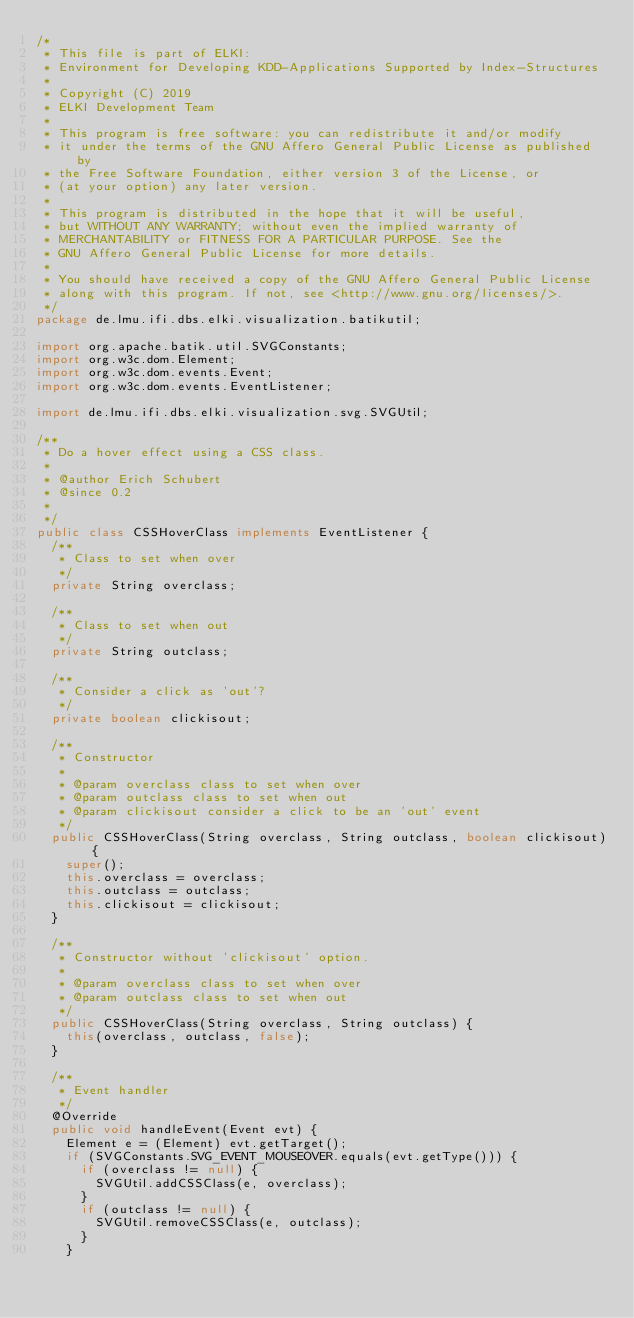Convert code to text. <code><loc_0><loc_0><loc_500><loc_500><_Java_>/*
 * This file is part of ELKI:
 * Environment for Developing KDD-Applications Supported by Index-Structures
 *
 * Copyright (C) 2019
 * ELKI Development Team
 *
 * This program is free software: you can redistribute it and/or modify
 * it under the terms of the GNU Affero General Public License as published by
 * the Free Software Foundation, either version 3 of the License, or
 * (at your option) any later version.
 *
 * This program is distributed in the hope that it will be useful,
 * but WITHOUT ANY WARRANTY; without even the implied warranty of
 * MERCHANTABILITY or FITNESS FOR A PARTICULAR PURPOSE. See the
 * GNU Affero General Public License for more details.
 *
 * You should have received a copy of the GNU Affero General Public License
 * along with this program. If not, see <http://www.gnu.org/licenses/>.
 */
package de.lmu.ifi.dbs.elki.visualization.batikutil;

import org.apache.batik.util.SVGConstants;
import org.w3c.dom.Element;
import org.w3c.dom.events.Event;
import org.w3c.dom.events.EventListener;

import de.lmu.ifi.dbs.elki.visualization.svg.SVGUtil;

/**
 * Do a hover effect using a CSS class.
 *
 * @author Erich Schubert
 * @since 0.2
 *
 */
public class CSSHoverClass implements EventListener {
  /**
   * Class to set when over
   */
  private String overclass;

  /**
   * Class to set when out
   */
  private String outclass;

  /**
   * Consider a click as 'out'?
   */
  private boolean clickisout;

  /**
   * Constructor
   *
   * @param overclass class to set when over
   * @param outclass class to set when out
   * @param clickisout consider a click to be an 'out' event
   */
  public CSSHoverClass(String overclass, String outclass, boolean clickisout) {
    super();
    this.overclass = overclass;
    this.outclass = outclass;
    this.clickisout = clickisout;
  }

  /**
   * Constructor without 'clickisout' option.
   *
   * @param overclass class to set when over
   * @param outclass class to set when out
   */
  public CSSHoverClass(String overclass, String outclass) {
    this(overclass, outclass, false);
  }

  /**
   * Event handler
   */
  @Override
  public void handleEvent(Event evt) {
    Element e = (Element) evt.getTarget();
    if (SVGConstants.SVG_EVENT_MOUSEOVER.equals(evt.getType())) {
      if (overclass != null) {
        SVGUtil.addCSSClass(e, overclass);
      }
      if (outclass != null) {
        SVGUtil.removeCSSClass(e, outclass);
      }
    }</code> 